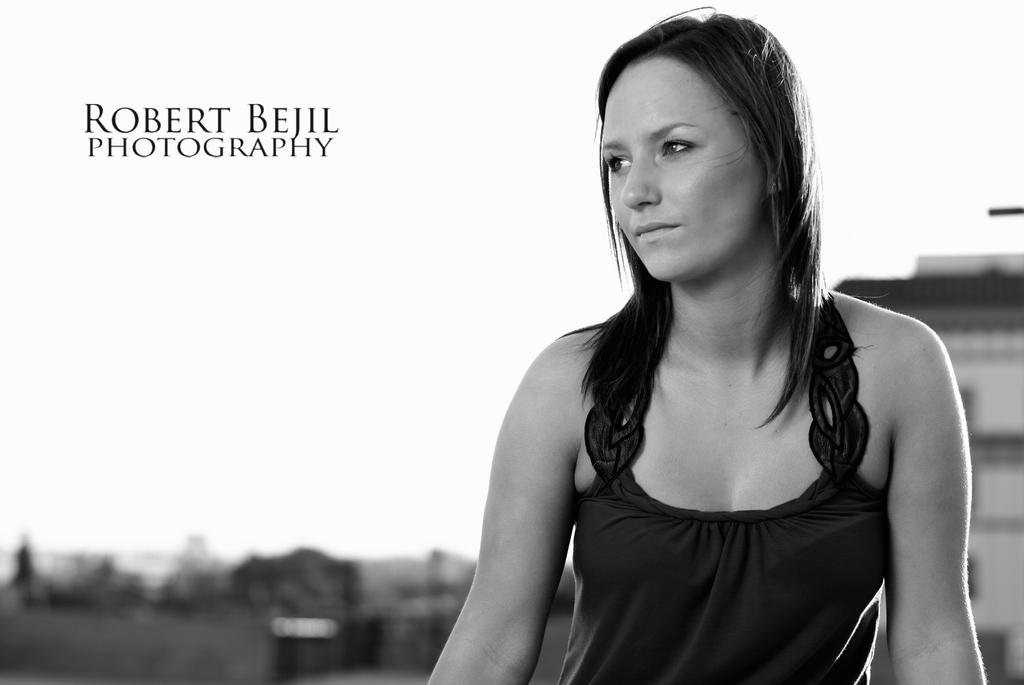Who is the main subject in the image? There is a woman in the image. What can be seen on the left side of the image? There is some text on the left side of the image. What is located on the right side of the image? There is a building on the right side of the image. How would you describe the background of the image? The background of the image is blurry. What type of battle is taking place in the image? There is no battle present in the image; it features a woman, text, a building, and a blurry background. How does the motion of the letter affect the overall composition of the image? There is no letter present in the image, so its motion cannot be assessed. 